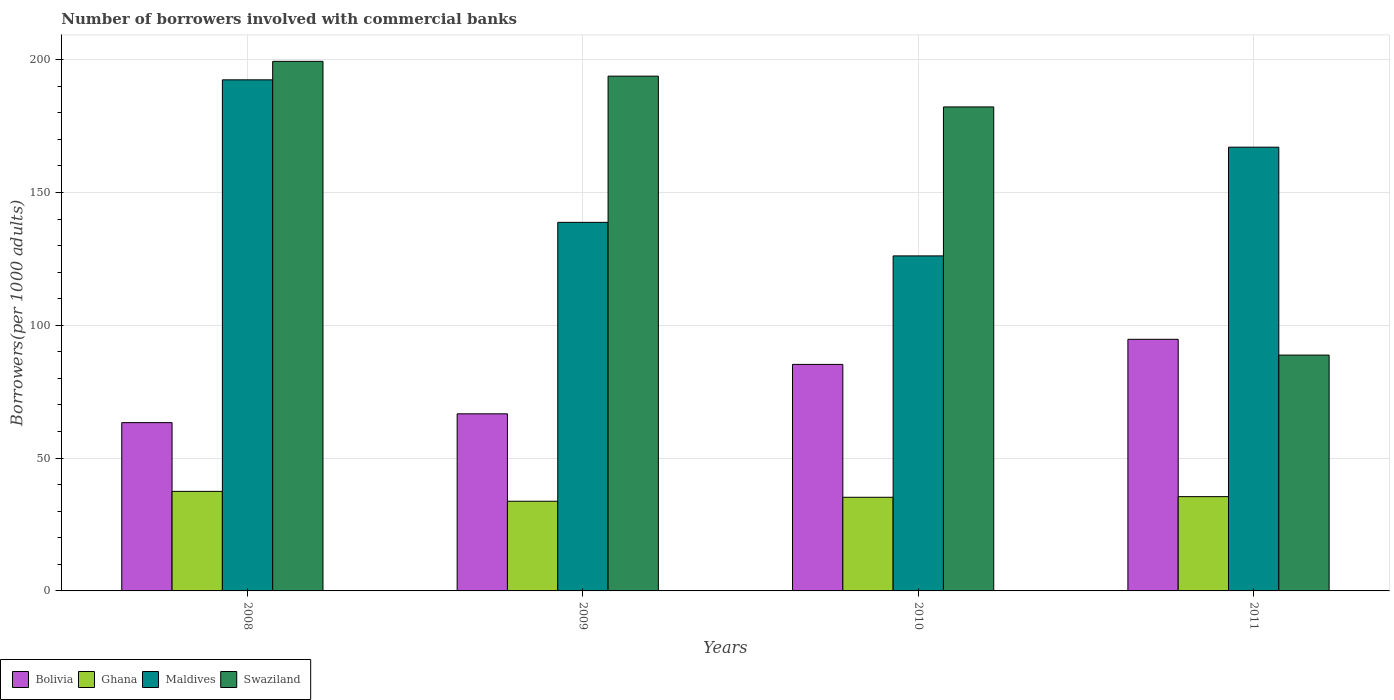How many different coloured bars are there?
Ensure brevity in your answer.  4. Are the number of bars per tick equal to the number of legend labels?
Give a very brief answer. Yes. Are the number of bars on each tick of the X-axis equal?
Ensure brevity in your answer.  Yes. How many bars are there on the 4th tick from the left?
Give a very brief answer. 4. How many bars are there on the 2nd tick from the right?
Ensure brevity in your answer.  4. What is the number of borrowers involved with commercial banks in Bolivia in 2009?
Provide a short and direct response. 66.68. Across all years, what is the maximum number of borrowers involved with commercial banks in Maldives?
Your response must be concise. 192.42. Across all years, what is the minimum number of borrowers involved with commercial banks in Maldives?
Provide a succinct answer. 126.14. What is the total number of borrowers involved with commercial banks in Swaziland in the graph?
Provide a succinct answer. 664.21. What is the difference between the number of borrowers involved with commercial banks in Swaziland in 2009 and that in 2011?
Your answer should be compact. 105.02. What is the difference between the number of borrowers involved with commercial banks in Bolivia in 2011 and the number of borrowers involved with commercial banks in Maldives in 2008?
Your answer should be very brief. -97.69. What is the average number of borrowers involved with commercial banks in Maldives per year?
Your answer should be very brief. 156.1. In the year 2009, what is the difference between the number of borrowers involved with commercial banks in Maldives and number of borrowers involved with commercial banks in Bolivia?
Ensure brevity in your answer.  72.09. What is the ratio of the number of borrowers involved with commercial banks in Maldives in 2008 to that in 2011?
Your response must be concise. 1.15. Is the difference between the number of borrowers involved with commercial banks in Maldives in 2008 and 2010 greater than the difference between the number of borrowers involved with commercial banks in Bolivia in 2008 and 2010?
Your answer should be compact. Yes. What is the difference between the highest and the second highest number of borrowers involved with commercial banks in Bolivia?
Ensure brevity in your answer.  9.45. What is the difference between the highest and the lowest number of borrowers involved with commercial banks in Maldives?
Your answer should be very brief. 66.29. Is it the case that in every year, the sum of the number of borrowers involved with commercial banks in Swaziland and number of borrowers involved with commercial banks in Bolivia is greater than the sum of number of borrowers involved with commercial banks in Ghana and number of borrowers involved with commercial banks in Maldives?
Provide a succinct answer. Yes. What does the 2nd bar from the right in 2011 represents?
Your answer should be very brief. Maldives. What is the difference between two consecutive major ticks on the Y-axis?
Keep it short and to the point. 50. Where does the legend appear in the graph?
Provide a short and direct response. Bottom left. What is the title of the graph?
Offer a terse response. Number of borrowers involved with commercial banks. What is the label or title of the Y-axis?
Offer a very short reply. Borrowers(per 1000 adults). What is the Borrowers(per 1000 adults) in Bolivia in 2008?
Keep it short and to the point. 63.36. What is the Borrowers(per 1000 adults) of Ghana in 2008?
Provide a short and direct response. 37.48. What is the Borrowers(per 1000 adults) in Maldives in 2008?
Make the answer very short. 192.42. What is the Borrowers(per 1000 adults) in Swaziland in 2008?
Provide a succinct answer. 199.38. What is the Borrowers(per 1000 adults) in Bolivia in 2009?
Offer a very short reply. 66.68. What is the Borrowers(per 1000 adults) of Ghana in 2009?
Ensure brevity in your answer.  33.76. What is the Borrowers(per 1000 adults) of Maldives in 2009?
Your response must be concise. 138.77. What is the Borrowers(per 1000 adults) in Swaziland in 2009?
Keep it short and to the point. 193.81. What is the Borrowers(per 1000 adults) of Bolivia in 2010?
Your response must be concise. 85.29. What is the Borrowers(per 1000 adults) in Ghana in 2010?
Provide a succinct answer. 35.26. What is the Borrowers(per 1000 adults) of Maldives in 2010?
Keep it short and to the point. 126.14. What is the Borrowers(per 1000 adults) in Swaziland in 2010?
Your answer should be compact. 182.22. What is the Borrowers(per 1000 adults) in Bolivia in 2011?
Keep it short and to the point. 94.73. What is the Borrowers(per 1000 adults) of Ghana in 2011?
Offer a terse response. 35.5. What is the Borrowers(per 1000 adults) in Maldives in 2011?
Offer a terse response. 167.07. What is the Borrowers(per 1000 adults) of Swaziland in 2011?
Offer a very short reply. 88.79. Across all years, what is the maximum Borrowers(per 1000 adults) of Bolivia?
Offer a terse response. 94.73. Across all years, what is the maximum Borrowers(per 1000 adults) in Ghana?
Your answer should be very brief. 37.48. Across all years, what is the maximum Borrowers(per 1000 adults) in Maldives?
Make the answer very short. 192.42. Across all years, what is the maximum Borrowers(per 1000 adults) in Swaziland?
Keep it short and to the point. 199.38. Across all years, what is the minimum Borrowers(per 1000 adults) in Bolivia?
Keep it short and to the point. 63.36. Across all years, what is the minimum Borrowers(per 1000 adults) of Ghana?
Your answer should be very brief. 33.76. Across all years, what is the minimum Borrowers(per 1000 adults) of Maldives?
Provide a short and direct response. 126.14. Across all years, what is the minimum Borrowers(per 1000 adults) of Swaziland?
Offer a terse response. 88.79. What is the total Borrowers(per 1000 adults) in Bolivia in the graph?
Offer a very short reply. 310.05. What is the total Borrowers(per 1000 adults) of Ghana in the graph?
Your answer should be compact. 142. What is the total Borrowers(per 1000 adults) of Maldives in the graph?
Make the answer very short. 624.4. What is the total Borrowers(per 1000 adults) of Swaziland in the graph?
Provide a succinct answer. 664.21. What is the difference between the Borrowers(per 1000 adults) of Bolivia in 2008 and that in 2009?
Your response must be concise. -3.32. What is the difference between the Borrowers(per 1000 adults) of Ghana in 2008 and that in 2009?
Provide a short and direct response. 3.72. What is the difference between the Borrowers(per 1000 adults) in Maldives in 2008 and that in 2009?
Provide a short and direct response. 53.66. What is the difference between the Borrowers(per 1000 adults) of Swaziland in 2008 and that in 2009?
Offer a terse response. 5.57. What is the difference between the Borrowers(per 1000 adults) of Bolivia in 2008 and that in 2010?
Keep it short and to the point. -21.93. What is the difference between the Borrowers(per 1000 adults) in Ghana in 2008 and that in 2010?
Provide a succinct answer. 2.22. What is the difference between the Borrowers(per 1000 adults) of Maldives in 2008 and that in 2010?
Make the answer very short. 66.29. What is the difference between the Borrowers(per 1000 adults) of Swaziland in 2008 and that in 2010?
Keep it short and to the point. 17.16. What is the difference between the Borrowers(per 1000 adults) of Bolivia in 2008 and that in 2011?
Ensure brevity in your answer.  -31.37. What is the difference between the Borrowers(per 1000 adults) in Ghana in 2008 and that in 2011?
Offer a very short reply. 1.98. What is the difference between the Borrowers(per 1000 adults) in Maldives in 2008 and that in 2011?
Offer a very short reply. 25.36. What is the difference between the Borrowers(per 1000 adults) in Swaziland in 2008 and that in 2011?
Provide a short and direct response. 110.59. What is the difference between the Borrowers(per 1000 adults) of Bolivia in 2009 and that in 2010?
Your answer should be very brief. -18.61. What is the difference between the Borrowers(per 1000 adults) in Ghana in 2009 and that in 2010?
Your response must be concise. -1.5. What is the difference between the Borrowers(per 1000 adults) in Maldives in 2009 and that in 2010?
Your answer should be very brief. 12.63. What is the difference between the Borrowers(per 1000 adults) of Swaziland in 2009 and that in 2010?
Keep it short and to the point. 11.59. What is the difference between the Borrowers(per 1000 adults) in Bolivia in 2009 and that in 2011?
Make the answer very short. -28.05. What is the difference between the Borrowers(per 1000 adults) of Ghana in 2009 and that in 2011?
Offer a very short reply. -1.74. What is the difference between the Borrowers(per 1000 adults) in Maldives in 2009 and that in 2011?
Give a very brief answer. -28.3. What is the difference between the Borrowers(per 1000 adults) of Swaziland in 2009 and that in 2011?
Make the answer very short. 105.02. What is the difference between the Borrowers(per 1000 adults) in Bolivia in 2010 and that in 2011?
Give a very brief answer. -9.45. What is the difference between the Borrowers(per 1000 adults) of Ghana in 2010 and that in 2011?
Provide a succinct answer. -0.24. What is the difference between the Borrowers(per 1000 adults) of Maldives in 2010 and that in 2011?
Offer a terse response. -40.93. What is the difference between the Borrowers(per 1000 adults) of Swaziland in 2010 and that in 2011?
Offer a terse response. 93.43. What is the difference between the Borrowers(per 1000 adults) of Bolivia in 2008 and the Borrowers(per 1000 adults) of Ghana in 2009?
Offer a terse response. 29.6. What is the difference between the Borrowers(per 1000 adults) in Bolivia in 2008 and the Borrowers(per 1000 adults) in Maldives in 2009?
Your response must be concise. -75.41. What is the difference between the Borrowers(per 1000 adults) in Bolivia in 2008 and the Borrowers(per 1000 adults) in Swaziland in 2009?
Ensure brevity in your answer.  -130.45. What is the difference between the Borrowers(per 1000 adults) of Ghana in 2008 and the Borrowers(per 1000 adults) of Maldives in 2009?
Keep it short and to the point. -101.29. What is the difference between the Borrowers(per 1000 adults) in Ghana in 2008 and the Borrowers(per 1000 adults) in Swaziland in 2009?
Your answer should be compact. -156.33. What is the difference between the Borrowers(per 1000 adults) in Maldives in 2008 and the Borrowers(per 1000 adults) in Swaziland in 2009?
Provide a short and direct response. -1.39. What is the difference between the Borrowers(per 1000 adults) in Bolivia in 2008 and the Borrowers(per 1000 adults) in Ghana in 2010?
Make the answer very short. 28.1. What is the difference between the Borrowers(per 1000 adults) of Bolivia in 2008 and the Borrowers(per 1000 adults) of Maldives in 2010?
Ensure brevity in your answer.  -62.78. What is the difference between the Borrowers(per 1000 adults) of Bolivia in 2008 and the Borrowers(per 1000 adults) of Swaziland in 2010?
Provide a short and direct response. -118.86. What is the difference between the Borrowers(per 1000 adults) of Ghana in 2008 and the Borrowers(per 1000 adults) of Maldives in 2010?
Offer a terse response. -88.66. What is the difference between the Borrowers(per 1000 adults) in Ghana in 2008 and the Borrowers(per 1000 adults) in Swaziland in 2010?
Provide a succinct answer. -144.74. What is the difference between the Borrowers(per 1000 adults) in Maldives in 2008 and the Borrowers(per 1000 adults) in Swaziland in 2010?
Your answer should be very brief. 10.2. What is the difference between the Borrowers(per 1000 adults) of Bolivia in 2008 and the Borrowers(per 1000 adults) of Ghana in 2011?
Give a very brief answer. 27.86. What is the difference between the Borrowers(per 1000 adults) in Bolivia in 2008 and the Borrowers(per 1000 adults) in Maldives in 2011?
Your answer should be compact. -103.71. What is the difference between the Borrowers(per 1000 adults) of Bolivia in 2008 and the Borrowers(per 1000 adults) of Swaziland in 2011?
Offer a very short reply. -25.44. What is the difference between the Borrowers(per 1000 adults) of Ghana in 2008 and the Borrowers(per 1000 adults) of Maldives in 2011?
Make the answer very short. -129.58. What is the difference between the Borrowers(per 1000 adults) in Ghana in 2008 and the Borrowers(per 1000 adults) in Swaziland in 2011?
Offer a terse response. -51.31. What is the difference between the Borrowers(per 1000 adults) of Maldives in 2008 and the Borrowers(per 1000 adults) of Swaziland in 2011?
Your response must be concise. 103.63. What is the difference between the Borrowers(per 1000 adults) of Bolivia in 2009 and the Borrowers(per 1000 adults) of Ghana in 2010?
Keep it short and to the point. 31.42. What is the difference between the Borrowers(per 1000 adults) of Bolivia in 2009 and the Borrowers(per 1000 adults) of Maldives in 2010?
Provide a short and direct response. -59.46. What is the difference between the Borrowers(per 1000 adults) in Bolivia in 2009 and the Borrowers(per 1000 adults) in Swaziland in 2010?
Keep it short and to the point. -115.54. What is the difference between the Borrowers(per 1000 adults) in Ghana in 2009 and the Borrowers(per 1000 adults) in Maldives in 2010?
Ensure brevity in your answer.  -92.38. What is the difference between the Borrowers(per 1000 adults) of Ghana in 2009 and the Borrowers(per 1000 adults) of Swaziland in 2010?
Your answer should be compact. -148.46. What is the difference between the Borrowers(per 1000 adults) in Maldives in 2009 and the Borrowers(per 1000 adults) in Swaziland in 2010?
Provide a succinct answer. -43.45. What is the difference between the Borrowers(per 1000 adults) of Bolivia in 2009 and the Borrowers(per 1000 adults) of Ghana in 2011?
Provide a short and direct response. 31.18. What is the difference between the Borrowers(per 1000 adults) of Bolivia in 2009 and the Borrowers(per 1000 adults) of Maldives in 2011?
Your answer should be very brief. -100.39. What is the difference between the Borrowers(per 1000 adults) in Bolivia in 2009 and the Borrowers(per 1000 adults) in Swaziland in 2011?
Keep it short and to the point. -22.12. What is the difference between the Borrowers(per 1000 adults) of Ghana in 2009 and the Borrowers(per 1000 adults) of Maldives in 2011?
Make the answer very short. -133.3. What is the difference between the Borrowers(per 1000 adults) of Ghana in 2009 and the Borrowers(per 1000 adults) of Swaziland in 2011?
Keep it short and to the point. -55.03. What is the difference between the Borrowers(per 1000 adults) of Maldives in 2009 and the Borrowers(per 1000 adults) of Swaziland in 2011?
Your response must be concise. 49.97. What is the difference between the Borrowers(per 1000 adults) of Bolivia in 2010 and the Borrowers(per 1000 adults) of Ghana in 2011?
Make the answer very short. 49.79. What is the difference between the Borrowers(per 1000 adults) of Bolivia in 2010 and the Borrowers(per 1000 adults) of Maldives in 2011?
Give a very brief answer. -81.78. What is the difference between the Borrowers(per 1000 adults) of Bolivia in 2010 and the Borrowers(per 1000 adults) of Swaziland in 2011?
Your response must be concise. -3.51. What is the difference between the Borrowers(per 1000 adults) of Ghana in 2010 and the Borrowers(per 1000 adults) of Maldives in 2011?
Provide a short and direct response. -131.81. What is the difference between the Borrowers(per 1000 adults) in Ghana in 2010 and the Borrowers(per 1000 adults) in Swaziland in 2011?
Give a very brief answer. -53.53. What is the difference between the Borrowers(per 1000 adults) in Maldives in 2010 and the Borrowers(per 1000 adults) in Swaziland in 2011?
Keep it short and to the point. 37.34. What is the average Borrowers(per 1000 adults) of Bolivia per year?
Provide a succinct answer. 77.51. What is the average Borrowers(per 1000 adults) of Ghana per year?
Ensure brevity in your answer.  35.5. What is the average Borrowers(per 1000 adults) of Maldives per year?
Provide a short and direct response. 156.1. What is the average Borrowers(per 1000 adults) in Swaziland per year?
Make the answer very short. 166.05. In the year 2008, what is the difference between the Borrowers(per 1000 adults) of Bolivia and Borrowers(per 1000 adults) of Ghana?
Provide a short and direct response. 25.88. In the year 2008, what is the difference between the Borrowers(per 1000 adults) in Bolivia and Borrowers(per 1000 adults) in Maldives?
Give a very brief answer. -129.07. In the year 2008, what is the difference between the Borrowers(per 1000 adults) in Bolivia and Borrowers(per 1000 adults) in Swaziland?
Offer a very short reply. -136.02. In the year 2008, what is the difference between the Borrowers(per 1000 adults) of Ghana and Borrowers(per 1000 adults) of Maldives?
Your response must be concise. -154.94. In the year 2008, what is the difference between the Borrowers(per 1000 adults) in Ghana and Borrowers(per 1000 adults) in Swaziland?
Make the answer very short. -161.9. In the year 2008, what is the difference between the Borrowers(per 1000 adults) of Maldives and Borrowers(per 1000 adults) of Swaziland?
Your answer should be compact. -6.96. In the year 2009, what is the difference between the Borrowers(per 1000 adults) of Bolivia and Borrowers(per 1000 adults) of Ghana?
Your answer should be compact. 32.92. In the year 2009, what is the difference between the Borrowers(per 1000 adults) in Bolivia and Borrowers(per 1000 adults) in Maldives?
Offer a terse response. -72.09. In the year 2009, what is the difference between the Borrowers(per 1000 adults) in Bolivia and Borrowers(per 1000 adults) in Swaziland?
Offer a very short reply. -127.13. In the year 2009, what is the difference between the Borrowers(per 1000 adults) in Ghana and Borrowers(per 1000 adults) in Maldives?
Keep it short and to the point. -105.01. In the year 2009, what is the difference between the Borrowers(per 1000 adults) in Ghana and Borrowers(per 1000 adults) in Swaziland?
Your answer should be very brief. -160.05. In the year 2009, what is the difference between the Borrowers(per 1000 adults) of Maldives and Borrowers(per 1000 adults) of Swaziland?
Your answer should be very brief. -55.04. In the year 2010, what is the difference between the Borrowers(per 1000 adults) of Bolivia and Borrowers(per 1000 adults) of Ghana?
Offer a terse response. 50.03. In the year 2010, what is the difference between the Borrowers(per 1000 adults) in Bolivia and Borrowers(per 1000 adults) in Maldives?
Your answer should be compact. -40.85. In the year 2010, what is the difference between the Borrowers(per 1000 adults) of Bolivia and Borrowers(per 1000 adults) of Swaziland?
Your answer should be compact. -96.94. In the year 2010, what is the difference between the Borrowers(per 1000 adults) in Ghana and Borrowers(per 1000 adults) in Maldives?
Offer a terse response. -90.88. In the year 2010, what is the difference between the Borrowers(per 1000 adults) in Ghana and Borrowers(per 1000 adults) in Swaziland?
Offer a very short reply. -146.96. In the year 2010, what is the difference between the Borrowers(per 1000 adults) of Maldives and Borrowers(per 1000 adults) of Swaziland?
Keep it short and to the point. -56.08. In the year 2011, what is the difference between the Borrowers(per 1000 adults) of Bolivia and Borrowers(per 1000 adults) of Ghana?
Provide a succinct answer. 59.23. In the year 2011, what is the difference between the Borrowers(per 1000 adults) of Bolivia and Borrowers(per 1000 adults) of Maldives?
Your response must be concise. -72.33. In the year 2011, what is the difference between the Borrowers(per 1000 adults) in Bolivia and Borrowers(per 1000 adults) in Swaziland?
Your response must be concise. 5.94. In the year 2011, what is the difference between the Borrowers(per 1000 adults) in Ghana and Borrowers(per 1000 adults) in Maldives?
Keep it short and to the point. -131.57. In the year 2011, what is the difference between the Borrowers(per 1000 adults) in Ghana and Borrowers(per 1000 adults) in Swaziland?
Your answer should be compact. -53.29. In the year 2011, what is the difference between the Borrowers(per 1000 adults) in Maldives and Borrowers(per 1000 adults) in Swaziland?
Your answer should be very brief. 78.27. What is the ratio of the Borrowers(per 1000 adults) in Bolivia in 2008 to that in 2009?
Keep it short and to the point. 0.95. What is the ratio of the Borrowers(per 1000 adults) in Ghana in 2008 to that in 2009?
Your answer should be very brief. 1.11. What is the ratio of the Borrowers(per 1000 adults) in Maldives in 2008 to that in 2009?
Ensure brevity in your answer.  1.39. What is the ratio of the Borrowers(per 1000 adults) in Swaziland in 2008 to that in 2009?
Ensure brevity in your answer.  1.03. What is the ratio of the Borrowers(per 1000 adults) in Bolivia in 2008 to that in 2010?
Offer a terse response. 0.74. What is the ratio of the Borrowers(per 1000 adults) of Ghana in 2008 to that in 2010?
Offer a very short reply. 1.06. What is the ratio of the Borrowers(per 1000 adults) in Maldives in 2008 to that in 2010?
Make the answer very short. 1.53. What is the ratio of the Borrowers(per 1000 adults) in Swaziland in 2008 to that in 2010?
Offer a very short reply. 1.09. What is the ratio of the Borrowers(per 1000 adults) in Bolivia in 2008 to that in 2011?
Give a very brief answer. 0.67. What is the ratio of the Borrowers(per 1000 adults) in Ghana in 2008 to that in 2011?
Provide a succinct answer. 1.06. What is the ratio of the Borrowers(per 1000 adults) of Maldives in 2008 to that in 2011?
Offer a very short reply. 1.15. What is the ratio of the Borrowers(per 1000 adults) of Swaziland in 2008 to that in 2011?
Ensure brevity in your answer.  2.25. What is the ratio of the Borrowers(per 1000 adults) of Bolivia in 2009 to that in 2010?
Provide a short and direct response. 0.78. What is the ratio of the Borrowers(per 1000 adults) in Ghana in 2009 to that in 2010?
Your response must be concise. 0.96. What is the ratio of the Borrowers(per 1000 adults) in Maldives in 2009 to that in 2010?
Keep it short and to the point. 1.1. What is the ratio of the Borrowers(per 1000 adults) of Swaziland in 2009 to that in 2010?
Your answer should be compact. 1.06. What is the ratio of the Borrowers(per 1000 adults) in Bolivia in 2009 to that in 2011?
Your answer should be compact. 0.7. What is the ratio of the Borrowers(per 1000 adults) in Ghana in 2009 to that in 2011?
Offer a very short reply. 0.95. What is the ratio of the Borrowers(per 1000 adults) of Maldives in 2009 to that in 2011?
Your response must be concise. 0.83. What is the ratio of the Borrowers(per 1000 adults) in Swaziland in 2009 to that in 2011?
Your answer should be compact. 2.18. What is the ratio of the Borrowers(per 1000 adults) in Bolivia in 2010 to that in 2011?
Keep it short and to the point. 0.9. What is the ratio of the Borrowers(per 1000 adults) of Maldives in 2010 to that in 2011?
Give a very brief answer. 0.76. What is the ratio of the Borrowers(per 1000 adults) in Swaziland in 2010 to that in 2011?
Provide a short and direct response. 2.05. What is the difference between the highest and the second highest Borrowers(per 1000 adults) in Bolivia?
Your response must be concise. 9.45. What is the difference between the highest and the second highest Borrowers(per 1000 adults) of Ghana?
Keep it short and to the point. 1.98. What is the difference between the highest and the second highest Borrowers(per 1000 adults) in Maldives?
Offer a very short reply. 25.36. What is the difference between the highest and the second highest Borrowers(per 1000 adults) in Swaziland?
Make the answer very short. 5.57. What is the difference between the highest and the lowest Borrowers(per 1000 adults) of Bolivia?
Your answer should be compact. 31.37. What is the difference between the highest and the lowest Borrowers(per 1000 adults) in Ghana?
Ensure brevity in your answer.  3.72. What is the difference between the highest and the lowest Borrowers(per 1000 adults) of Maldives?
Keep it short and to the point. 66.29. What is the difference between the highest and the lowest Borrowers(per 1000 adults) in Swaziland?
Your response must be concise. 110.59. 